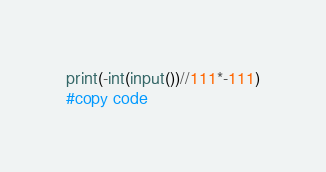<code> <loc_0><loc_0><loc_500><loc_500><_Python_>print(-int(input())//111*-111)
#copy code</code> 